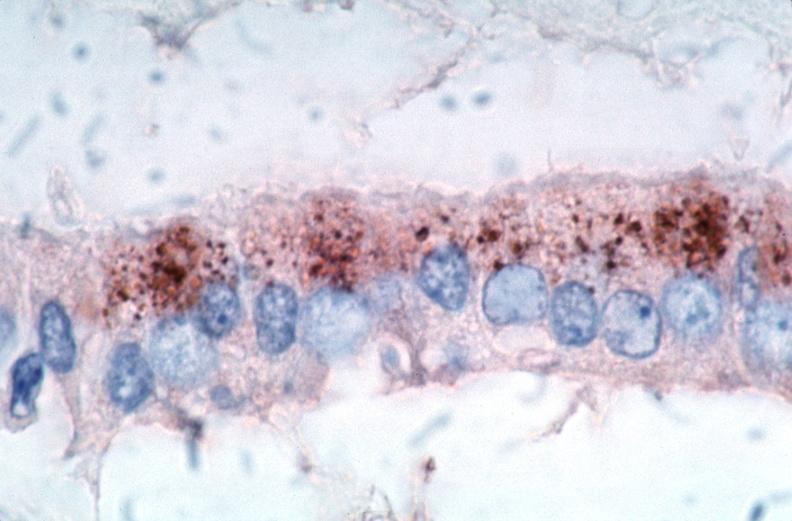s atrophy present?
Answer the question using a single word or phrase. No 